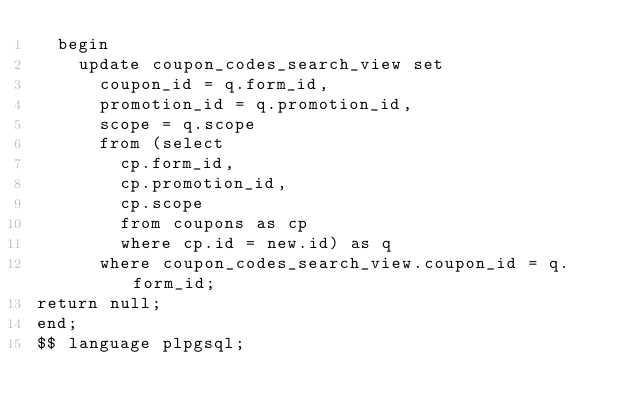Convert code to text. <code><loc_0><loc_0><loc_500><loc_500><_SQL_>  begin
    update coupon_codes_search_view set
      coupon_id = q.form_id,
      promotion_id = q.promotion_id,
      scope = q.scope
      from (select
        cp.form_id,
        cp.promotion_id,
        cp.scope
        from coupons as cp
        where cp.id = new.id) as q
      where coupon_codes_search_view.coupon_id = q.form_id;
return null;
end;
$$ language plpgsql;

</code> 